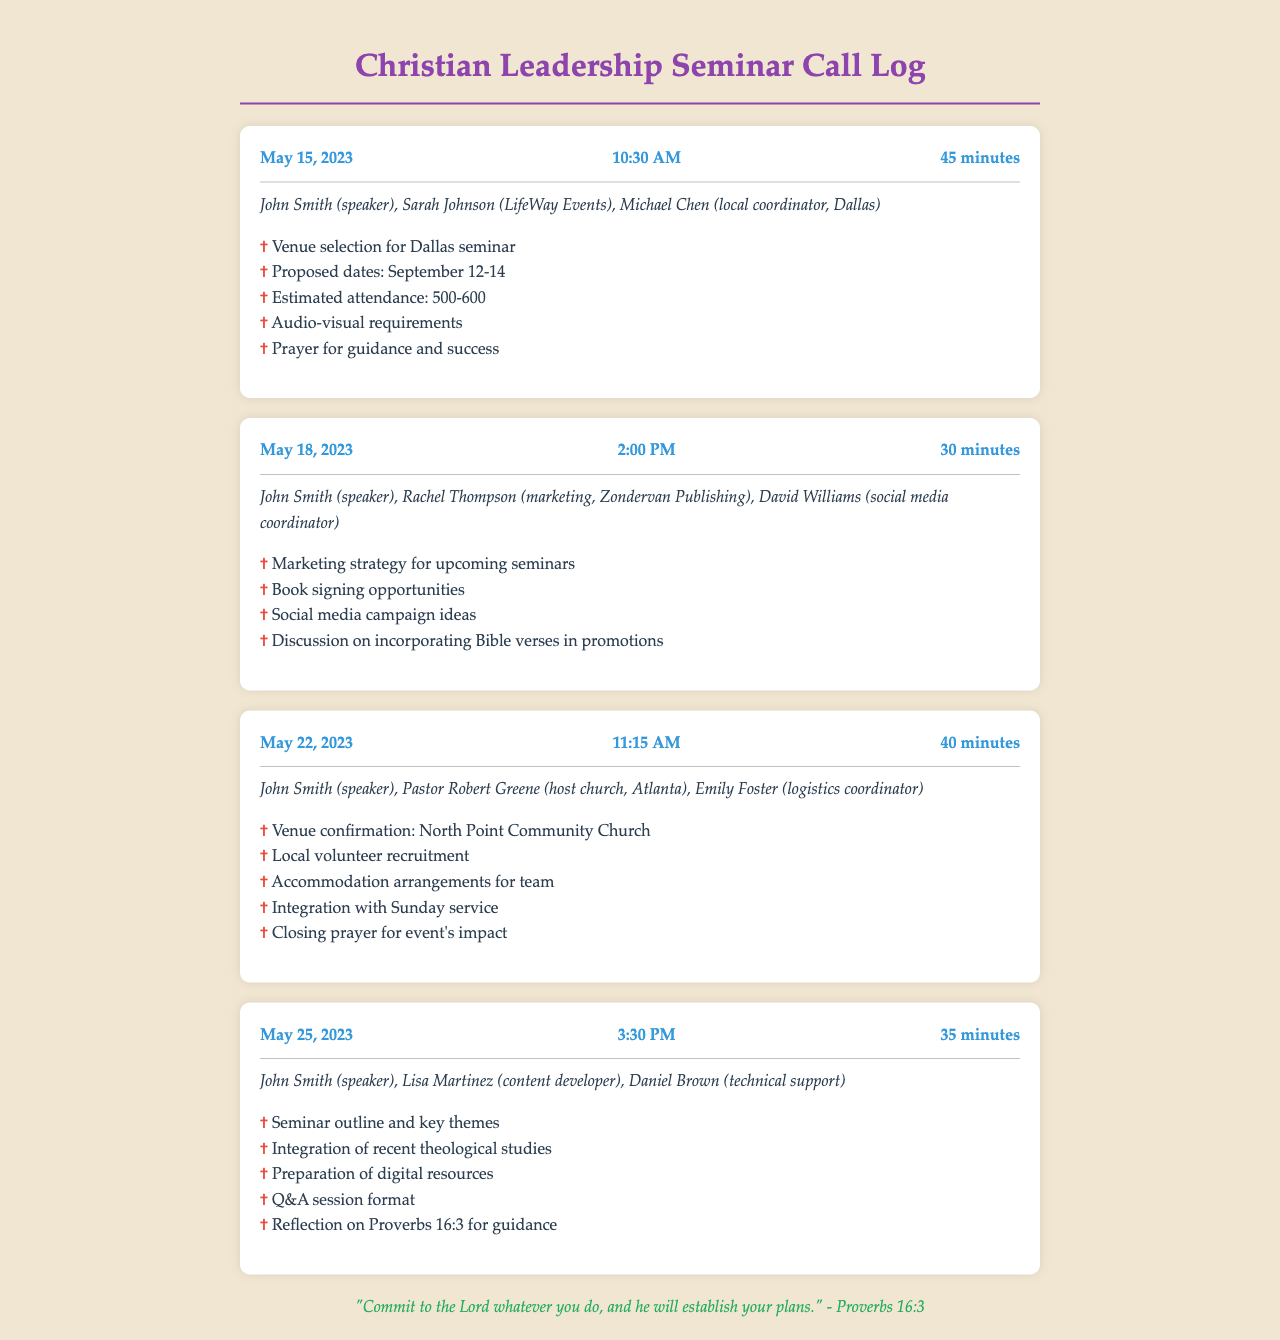What is the date of the first call? The date of the first call is mentioned as May 15, 2023.
Answer: May 15, 2023 Who participated in the call on May 22, 2023? The participants for the May 22, 2023 call included John Smith, Pastor Robert Greene, and Emily Foster.
Answer: John Smith, Pastor Robert Greene, Emily Foster How long was the call on May 18, 2023? The duration of the call on May 18, 2023 is stated as 30 minutes.
Answer: 30 minutes What was discussed during the May 25, 2023 call? The topics of discussion included the seminar outline, recent theological studies, and preparation of digital resources.
Answer: Seminar outline and key themes Which church hosted the Atlanta seminar? The host church for the Atlanta seminar is identified as North Point Community Church.
Answer: North Point Community Church How many estimated attendees were discussed for the Dallas seminar? The estimated attendance discussed for the Dallas seminar was between 500 to 600 individuals.
Answer: 500-600 What Bible verse is referenced in the document? The Bible verse mentioned in the document is Proverbs 16:3.
Answer: Proverbs 16:3 What was one of the topics for the marketing call on May 18? One of the topics discussed during the marketing call was the marketing strategy for upcoming seminars.
Answer: Marketing strategy for upcoming seminars 